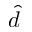<formula> <loc_0><loc_0><loc_500><loc_500>\hat { d }</formula> 